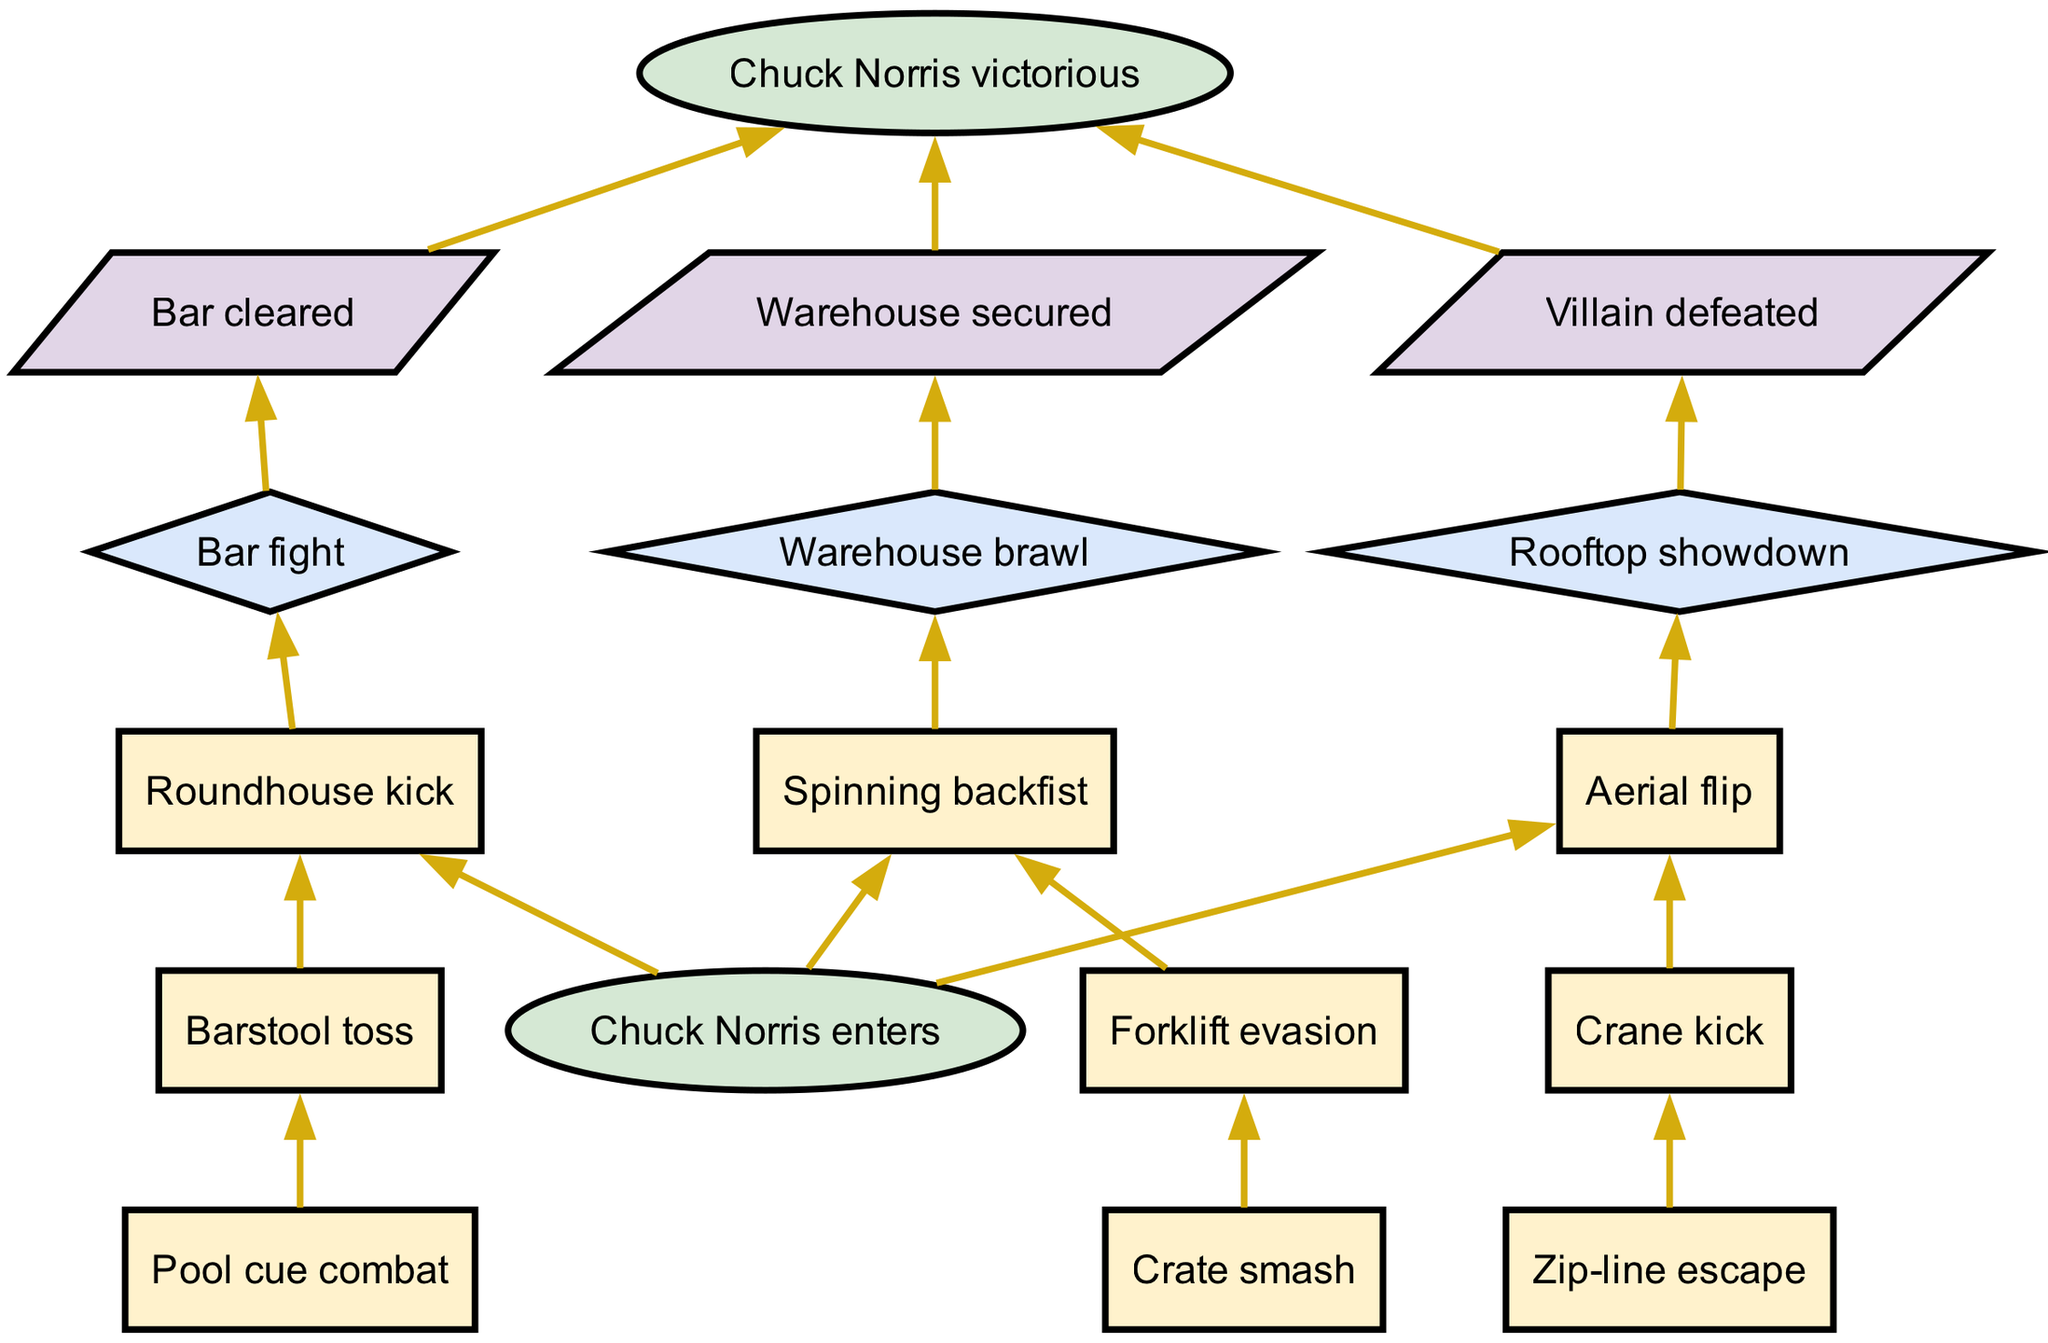What is the first action in the bar fight scenario? The first action listed under the bar fight scenario in the diagram is "Roundhouse kick." You locate the bar fight scenario, then look at the actions listed underneath it, identifying the first action as Roundhouse kick.
Answer: Roundhouse kick How many actions are there in the warehouse brawl? In the warehouse brawl scenario, there are three actions listed: "Spinning backfist," "Forklift evasion," and "Crate smash." You count each listed action to arrive at the total.
Answer: 3 What is the outcome of the rooftop showdown? The outcome for the rooftop showdown scenario is "Villain defeated." You trace the edge from the scenario node to the outcome node and read it directly.
Answer: Villain defeated Which action connects to the warehouse brawl outcome? The "Crate smash" action connects directly to the warehouse brawl outcome node. You follow the flow starting from the last action in the branch, which leads to the outcome node.
Answer: Crate smash How many scenarios are presented in the diagram? The diagram presents three scenarios: bar fight, warehouse brawl, and rooftop showdown. You simply count the distinct scenario nodes available in the branches section of the diagram.
Answer: 3 What action follows the "Forklift evasion" in the warehouse brawl scenario? The action that follows "Forklift evasion" is "Crate smash." You locate "Forklift evasion" and see that it connects to the next action in that sequence based on the diagram's structure.
Answer: Crate smash Which scenario leads to the outcome "Warehouse secured"? The scenario leading to the outcome "Warehouse secured" is the warehouse brawl. You track the outcome node back to the scenario node to see which branch it originates from.
Answer: Warehouse brawl What is the last action before Chuck Norris is victorious in each scenario? The last action before Chuck Norris is victorious in each scenario corresponds to the last action in each scenario's list: "Pool cue combat," "Crate smash," and "Zip-line escape." You examine each scenario's list of actions to identify the last one.
Answer: Pool cue combat, Crate smash, Zip-line escape 